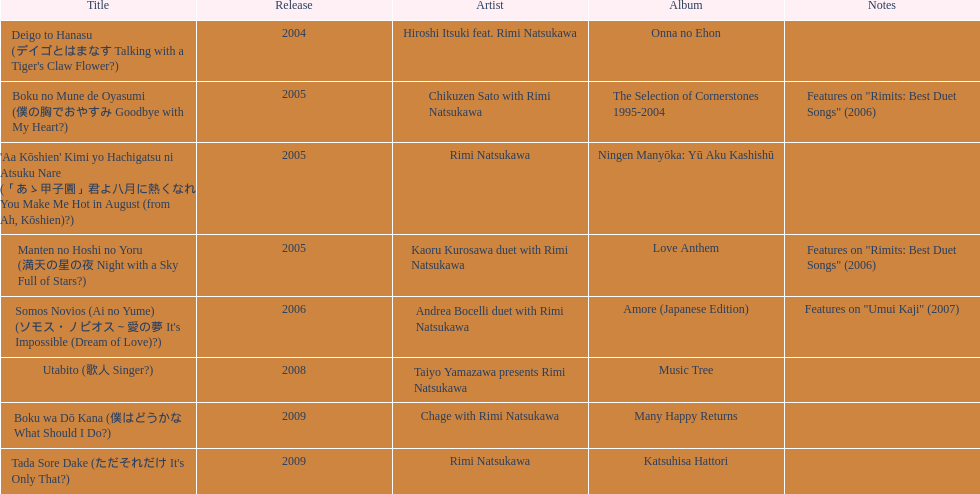When was the first title made available? 2004. 